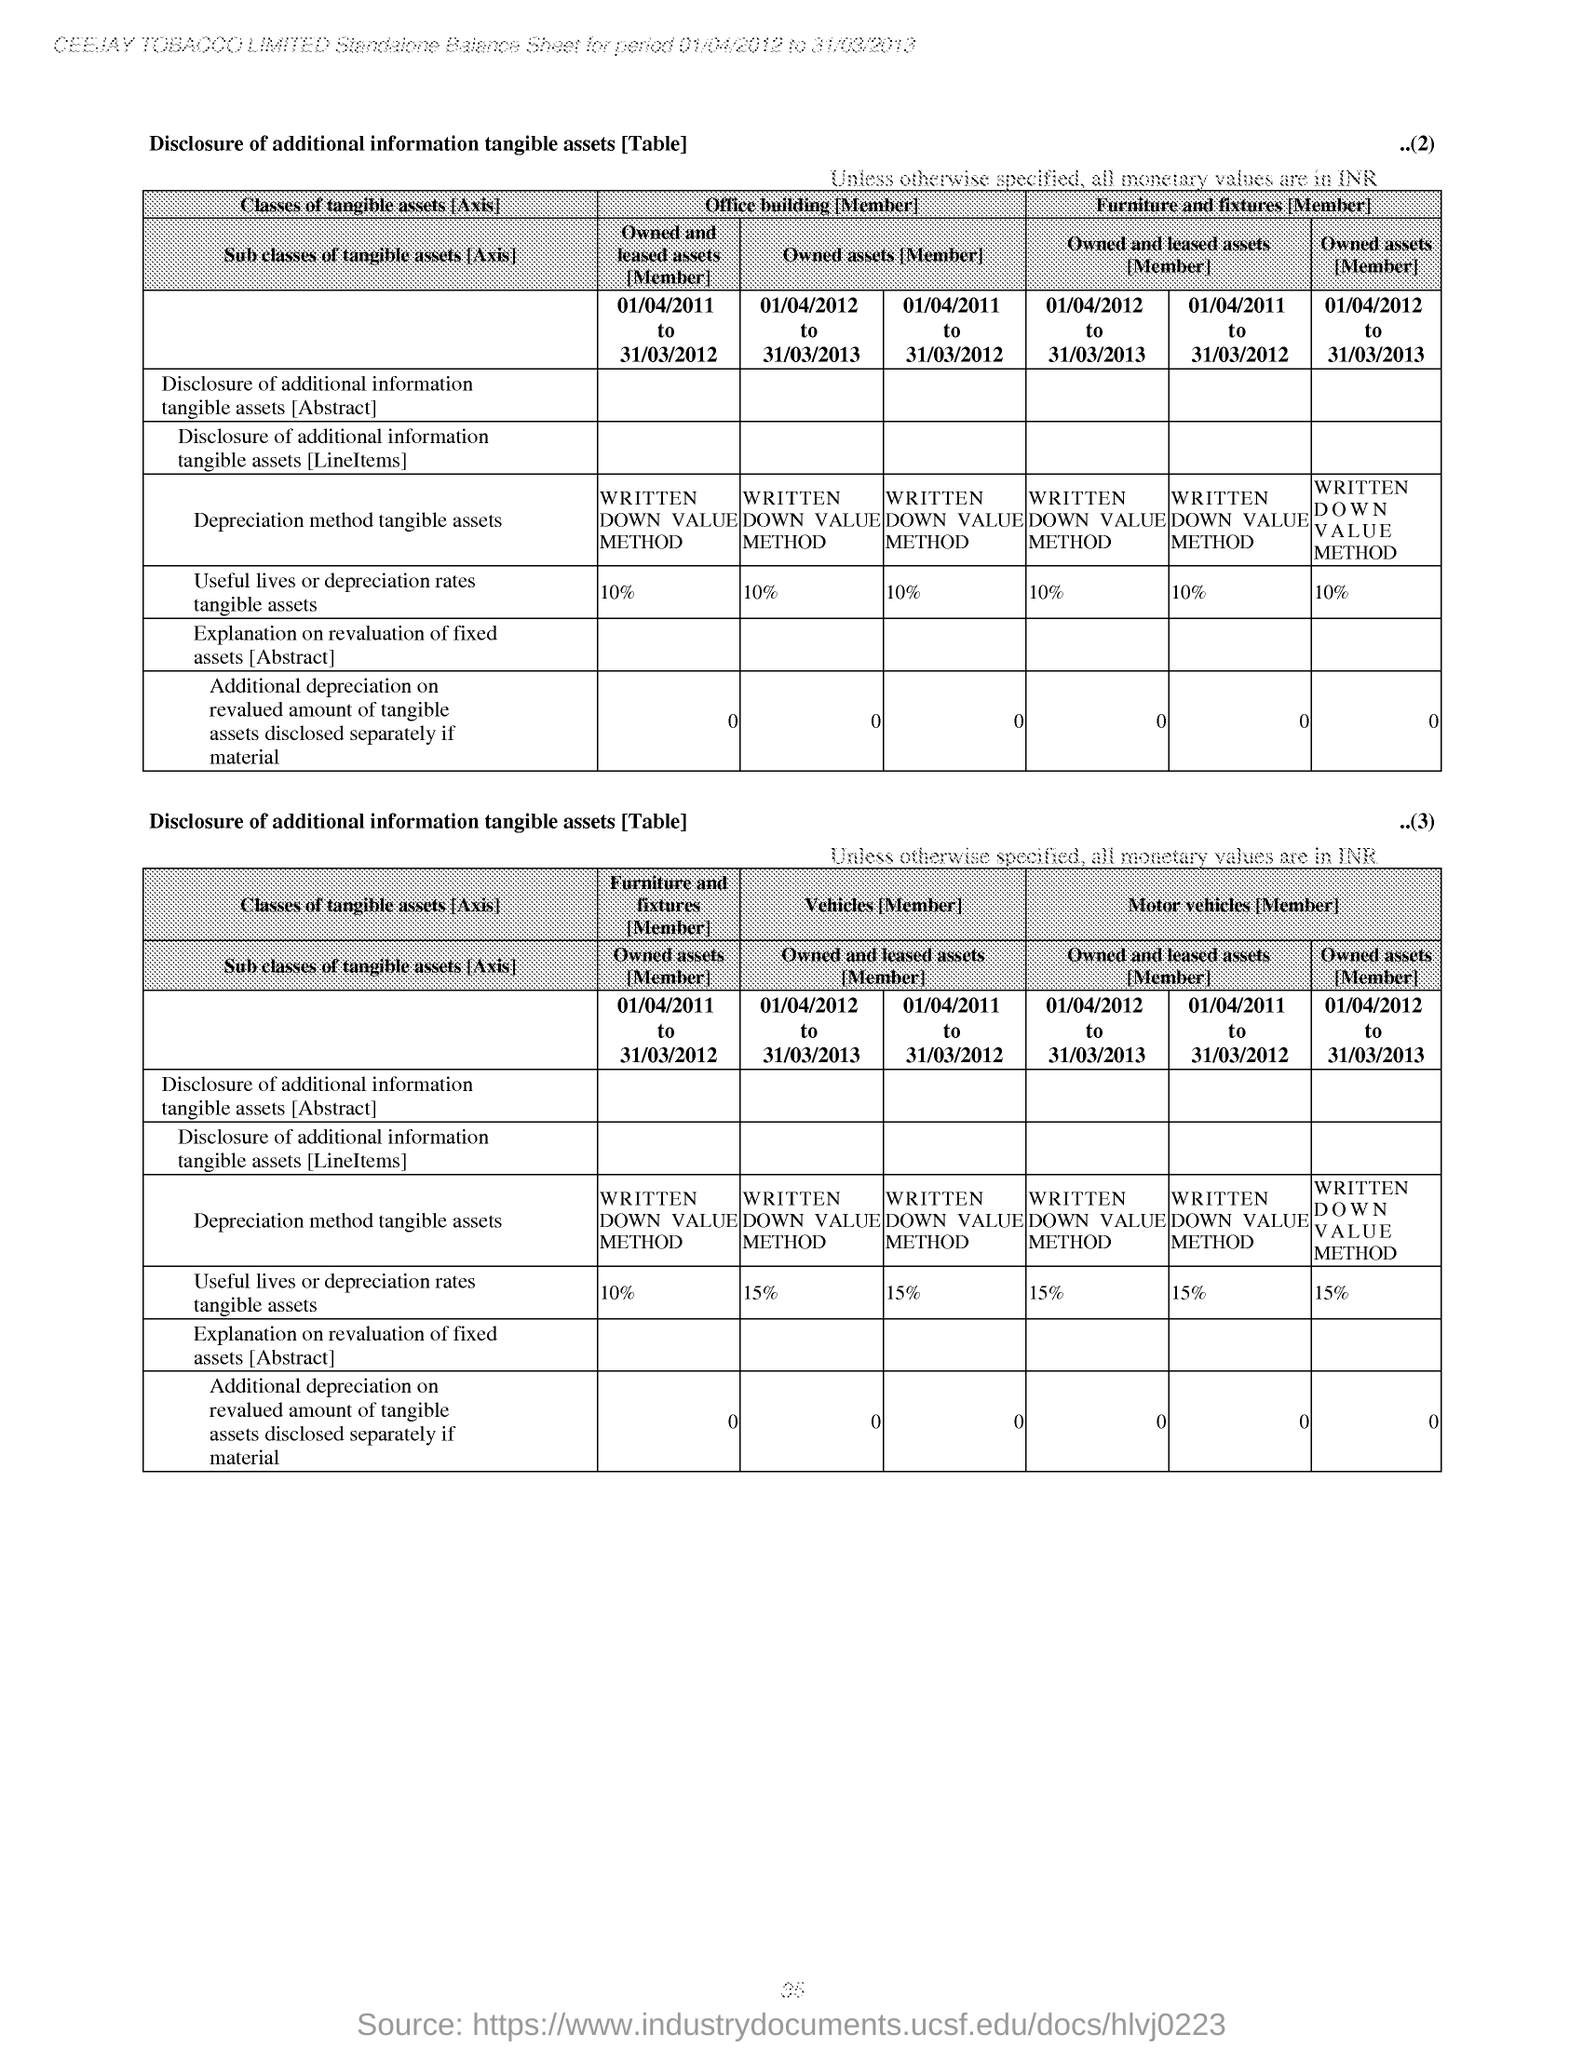What is the company name mentioned at the top of the page?
Give a very brief answer. CEEJAY TOBACCO LIMITED. From which period to which period  is the given Standalone Balance sheet made?
Keep it short and to the point. 01/04/2012 to 31/03/2013. Mention the number given at the right top corner of first table?
Your response must be concise. 2. Mention the heading given to the first table?
Keep it short and to the point. Disclosure of additional information tangible assets [Table]. Mention the "Useful lives or depriciation rates tangible assets" given in first table for all members?
Your answer should be very brief. 10%. Mention the "Useful lives or depriciation rates tangible assets" given in second table for "Furniture and fixtures[Member]?
Your answer should be compact. 10%. Mention the  number given at the right top corner of second table?
Offer a terse response. 3. What is the "Depreciation method tangible assets" given in both tables?
Your answer should be compact. Written down value method. 